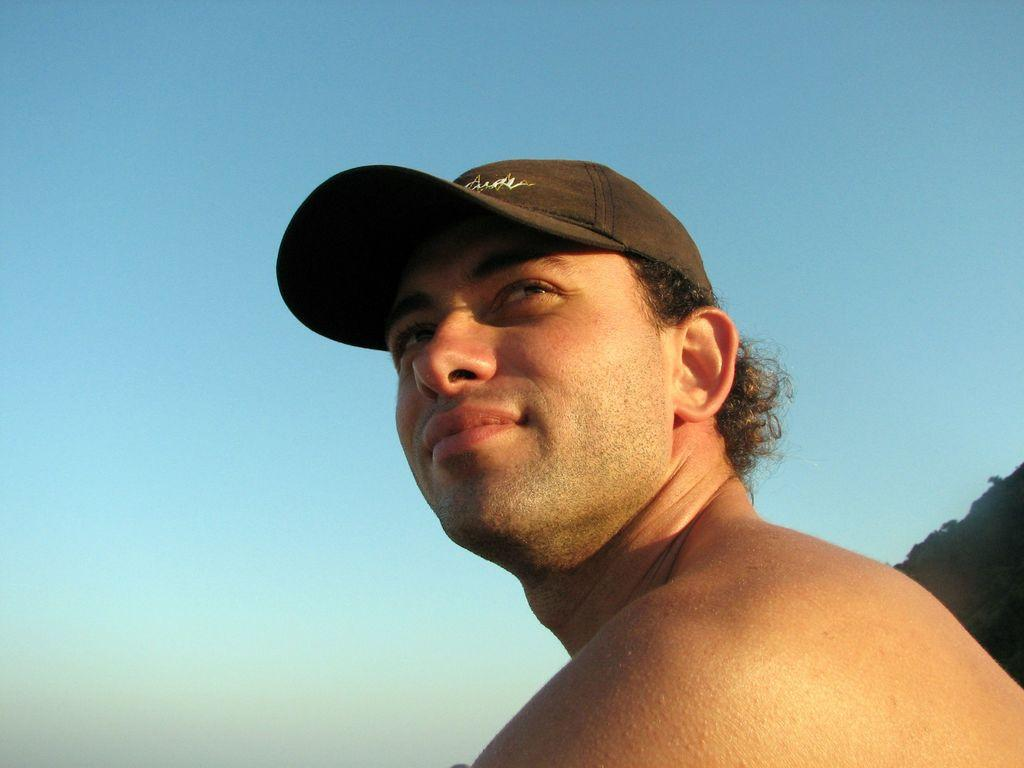What is the person in the image wearing on their head? The person in the image is wearing a cap. What can be seen in the background of the image? The background of the image includes a blue sky. What type of yak can be seen in the image? There is no yak present in the image. How many fowl are visible in the image? There are no fowl visible in the image; the image only features a person wearing a cap and a blue sky in the background. 